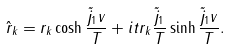<formula> <loc_0><loc_0><loc_500><loc_500>\hat { r } _ { k } = r _ { k } \cosh { \frac { \tilde { j } _ { 1 } v } { T } } + i t r _ { k } { \frac { \tilde { j } _ { 1 } } { T } } \sinh { \frac { \tilde { j } _ { 1 } v } { T } } .</formula> 